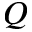Convert formula to latex. <formula><loc_0><loc_0><loc_500><loc_500>Q</formula> 